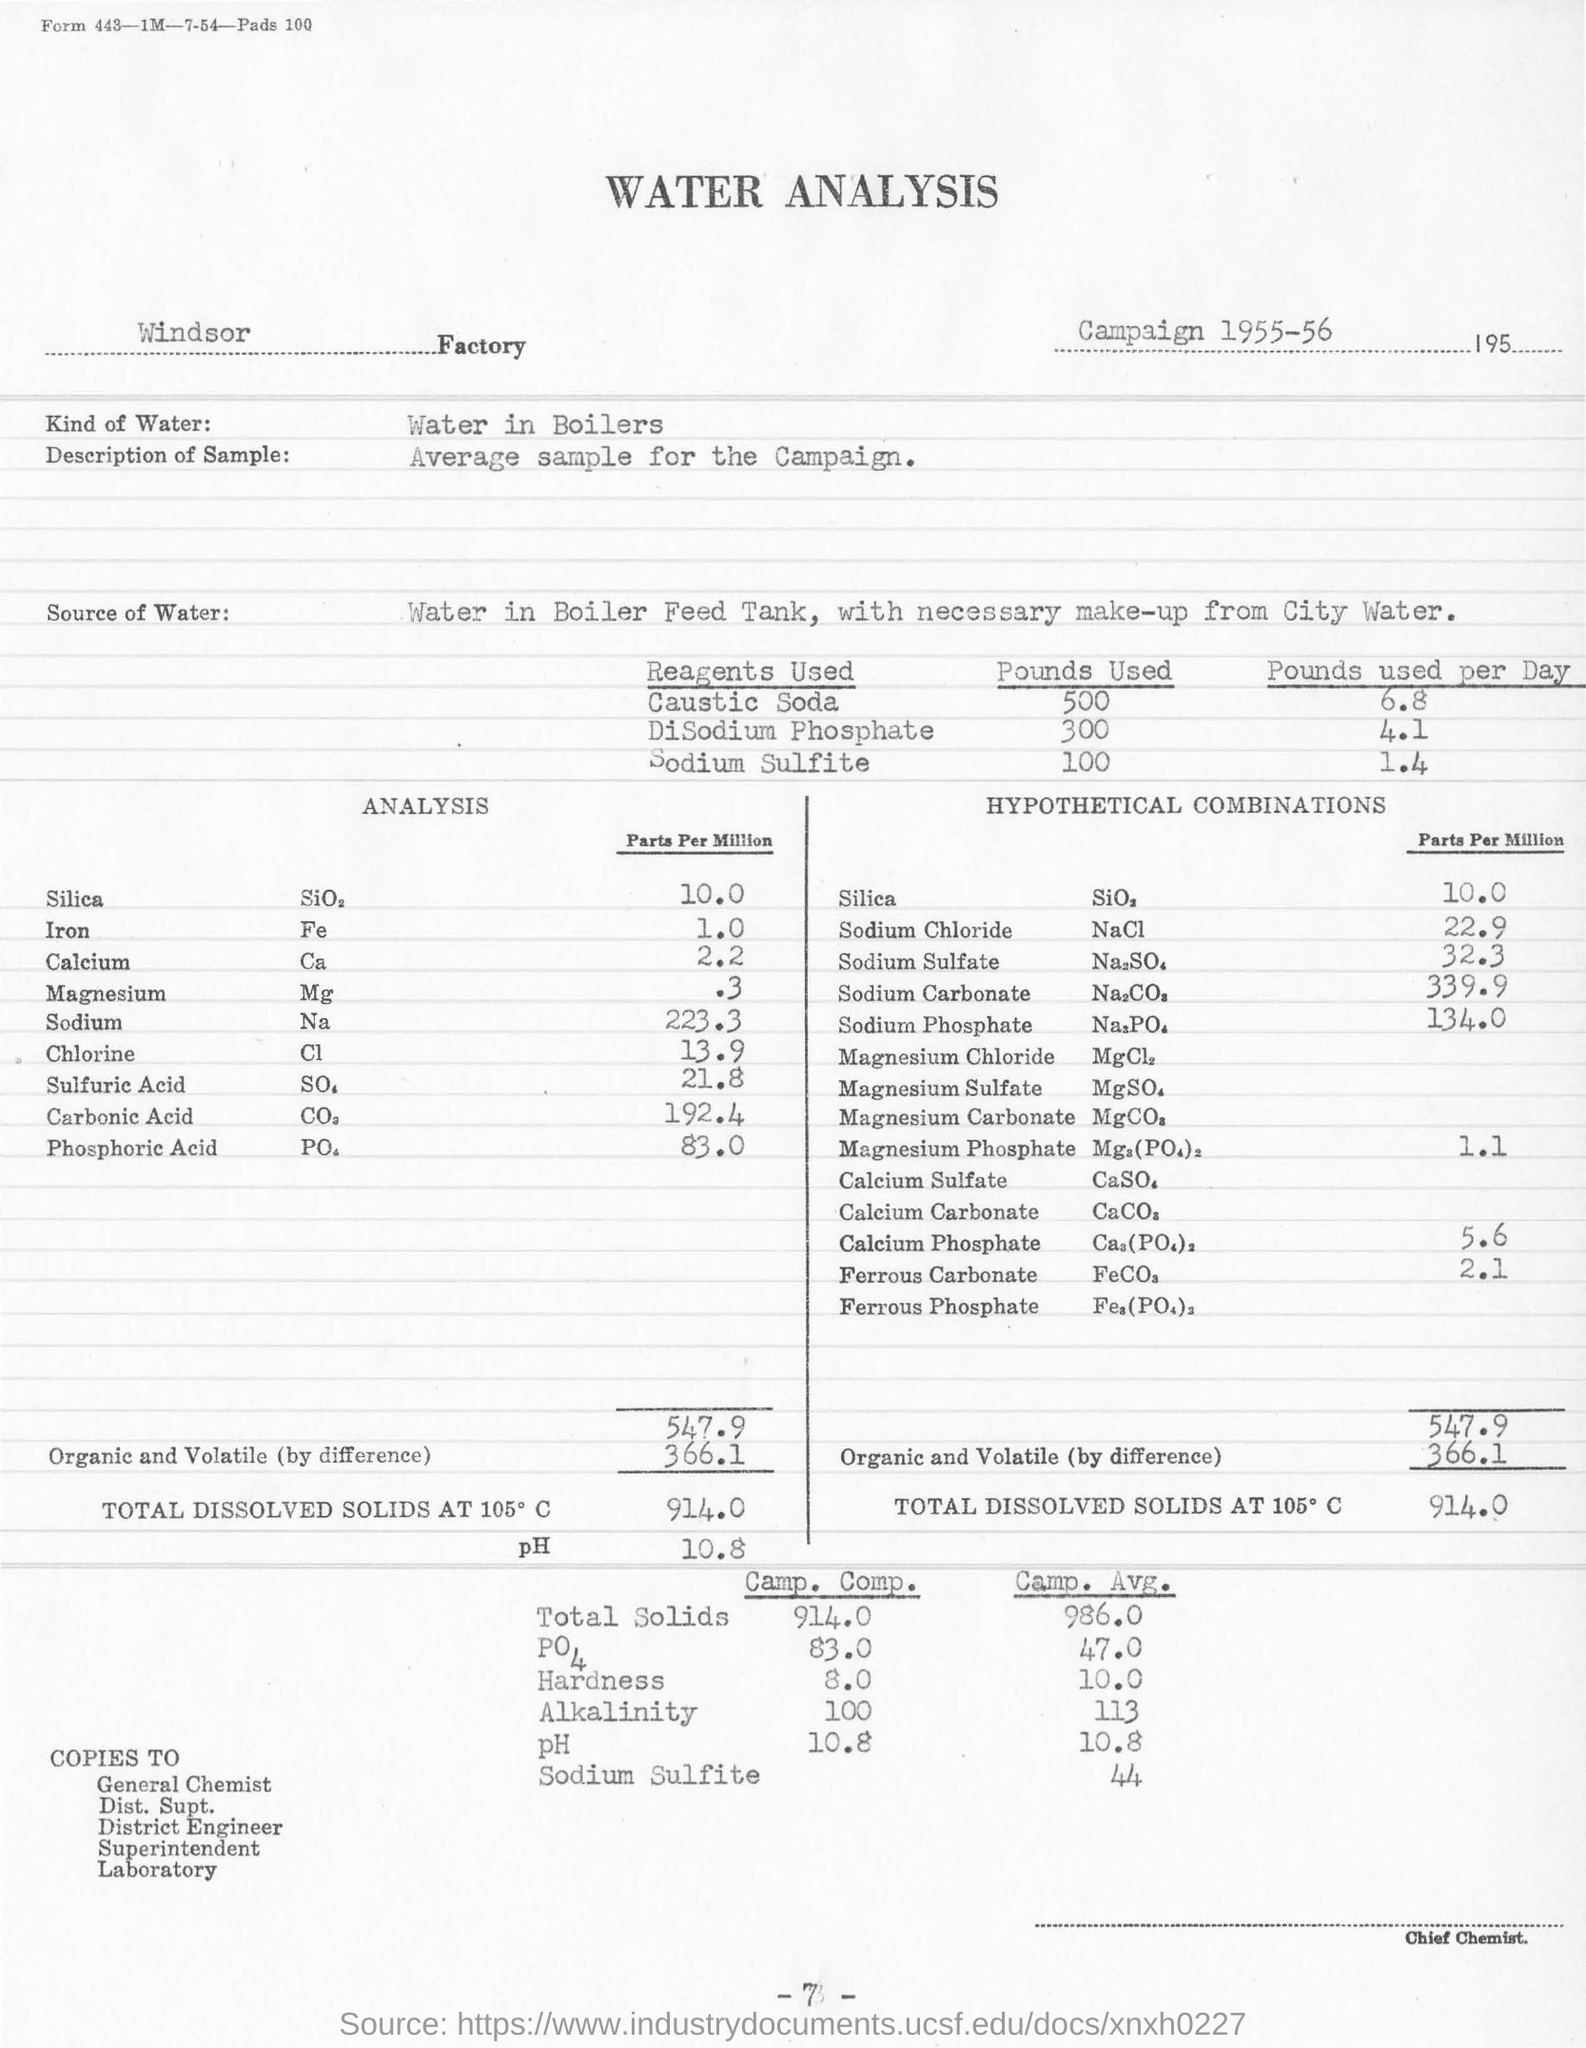Give some essential details in this illustration. The average sample for the campaign was described as "What is the Description of Sample? Average sample for the Campaign... Approximately 300 pounds of DiSodium Phosphate were used. It is important to consider the type of water being used, specifically in regards to boilers, as different types of water can impact the efficiency and functionality of the system. On average, 6.8 pounds of caustic soda are used per day. The year of the campaign is 1955-56. 